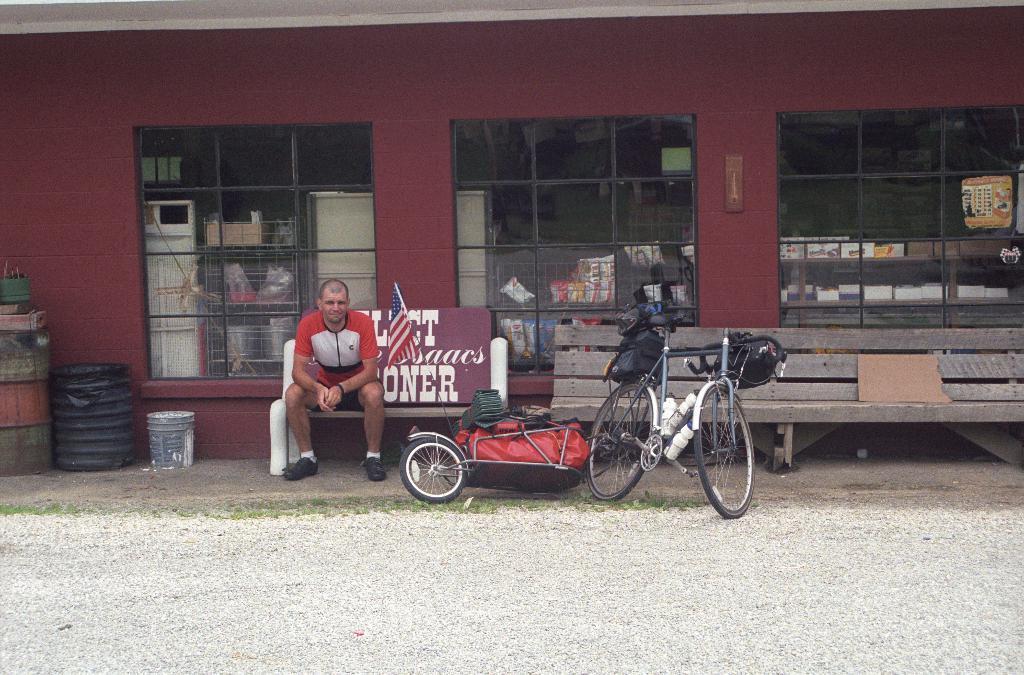Could you give a brief overview of what you see in this image? This person sitting on the bench. On the background we can see wall,glass windows,Containers,bucket,from this glass windows we can see things. We can see bags,bottles and objects on the vehicles. 